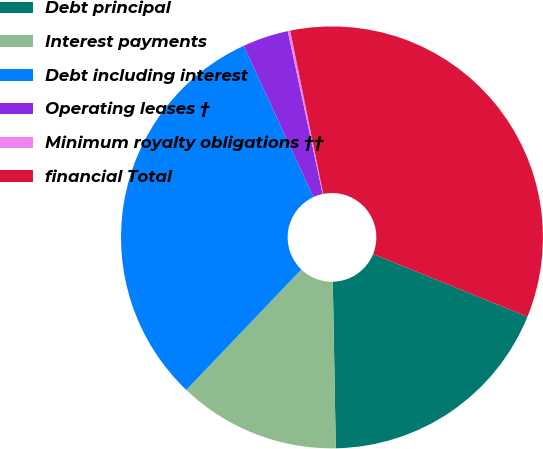Convert chart to OTSL. <chart><loc_0><loc_0><loc_500><loc_500><pie_chart><fcel>Debt principal<fcel>Interest payments<fcel>Debt including interest<fcel>Operating leases †<fcel>Minimum royalty obligations ††<fcel>financial Total<nl><fcel>18.58%<fcel>12.42%<fcel>31.0%<fcel>3.51%<fcel>0.19%<fcel>34.31%<nl></chart> 